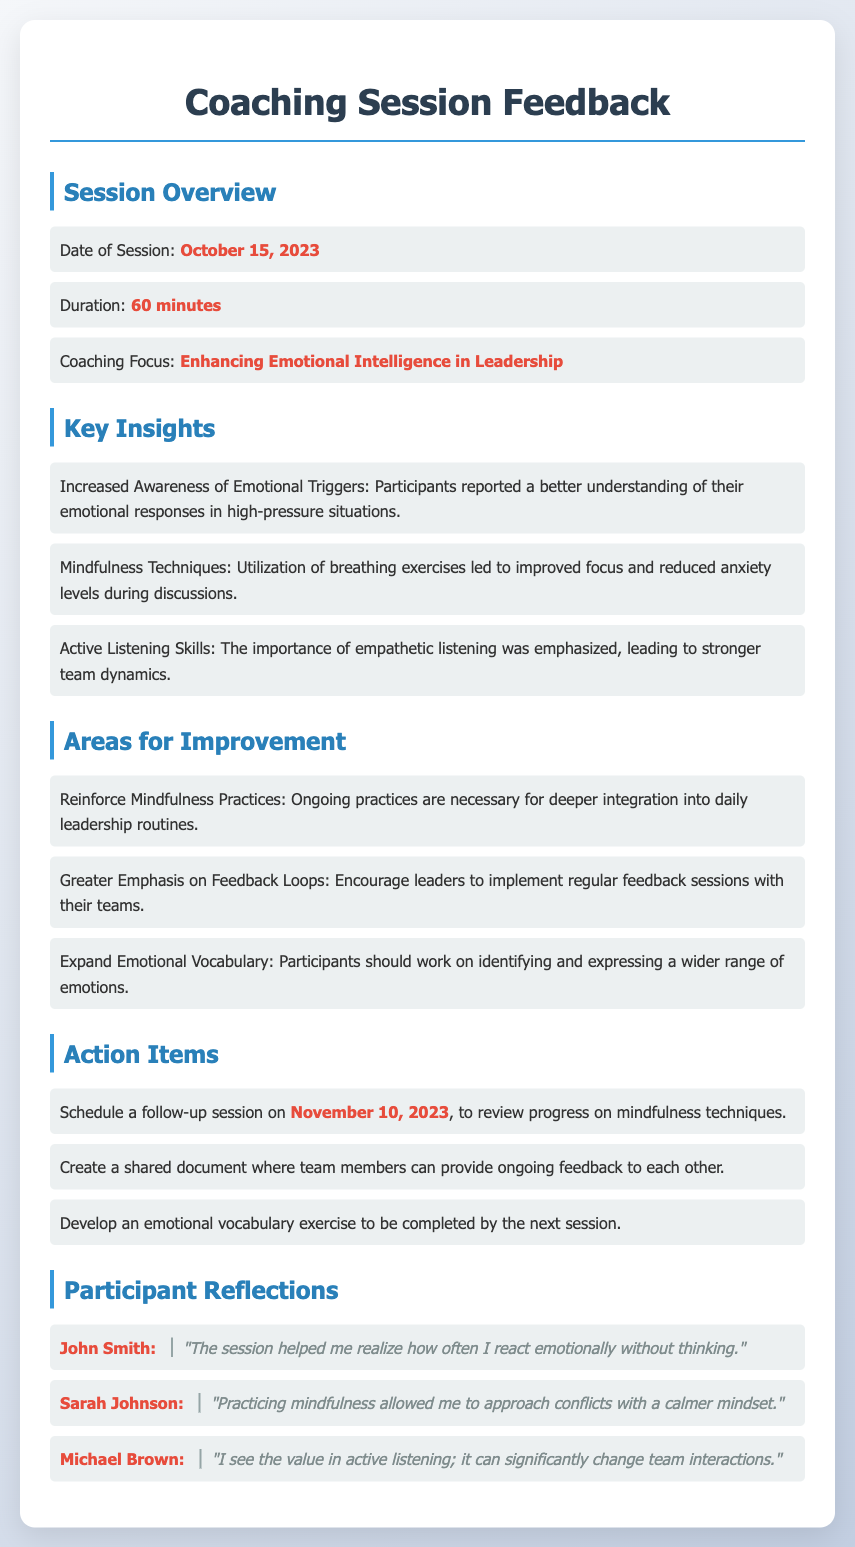What was the date of the session? The date of the session is stated in the document as October 15, 2023.
Answer: October 15, 2023 What was the duration of the coaching session? The document mentions that the duration of the session was 60 minutes.
Answer: 60 minutes What is the coaching focus mentioned? The document lists the coaching focus as enhancing emotional intelligence in leadership.
Answer: Enhancing Emotional Intelligence in Leadership What are the names of the participants? The document lists three participants: John Smith, Sarah Johnson, and Michael Brown.
Answer: John Smith, Sarah Johnson, Michael Brown Which mindfulness technique was noted for reducing anxiety? The document states that breathing exercises led to improved focus and reduced anxiety levels.
Answer: Breathing exercises What action item is scheduled for November 10, 2023? The document specifies a follow-up session to review progress on mindfulness techniques.
Answer: Review progress on mindfulness techniques What area for improvement emphasizes ongoing practices? The document highlights the need to reinforce mindfulness practices for deeper integration.
Answer: Reinforce Mindfulness Practices What feedback aspect should be encouraged among leaders? The document emphasizes encouraging leaders to implement regular feedback sessions with their teams.
Answer: Regular feedback sessions 